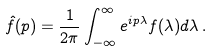Convert formula to latex. <formula><loc_0><loc_0><loc_500><loc_500>\hat { f } ( p ) = \frac { 1 } { 2 \pi } \int _ { - \infty } ^ { \infty } e ^ { i p \lambda } f ( \lambda ) d \lambda \, .</formula> 